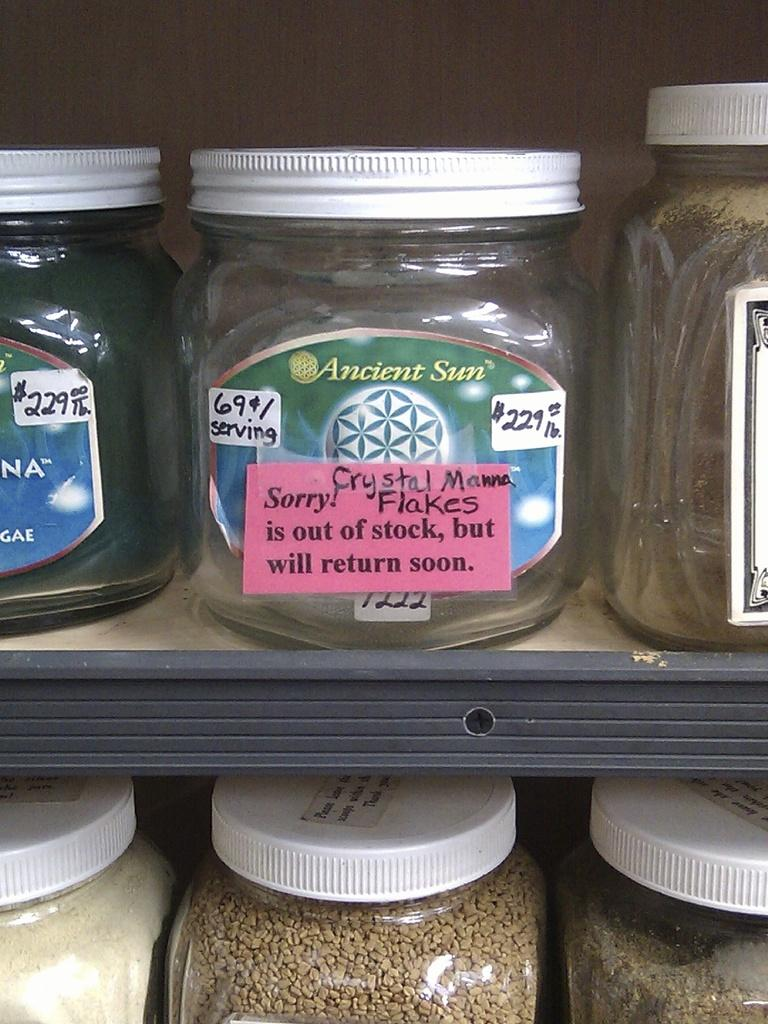<image>
Share a concise interpretation of the image provided. Crystal Manna Flakes are out of stock but will return soon. 